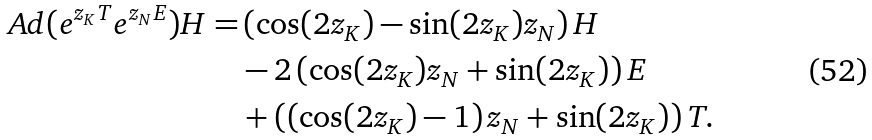<formula> <loc_0><loc_0><loc_500><loc_500>\ A d ( e ^ { z _ { K } T } e ^ { z _ { N } E } ) H = & \left ( \cos ( 2 z _ { K } ) - \sin ( 2 z _ { K } ) z _ { N } \right ) H \\ & - 2 \left ( \cos ( 2 z _ { K } ) z _ { N } + \sin ( 2 z _ { K } ) \right ) E \\ & + \left ( \left ( \cos ( 2 z _ { K } ) - 1 \right ) z _ { N } + \sin ( 2 z _ { K } ) \right ) T .</formula> 